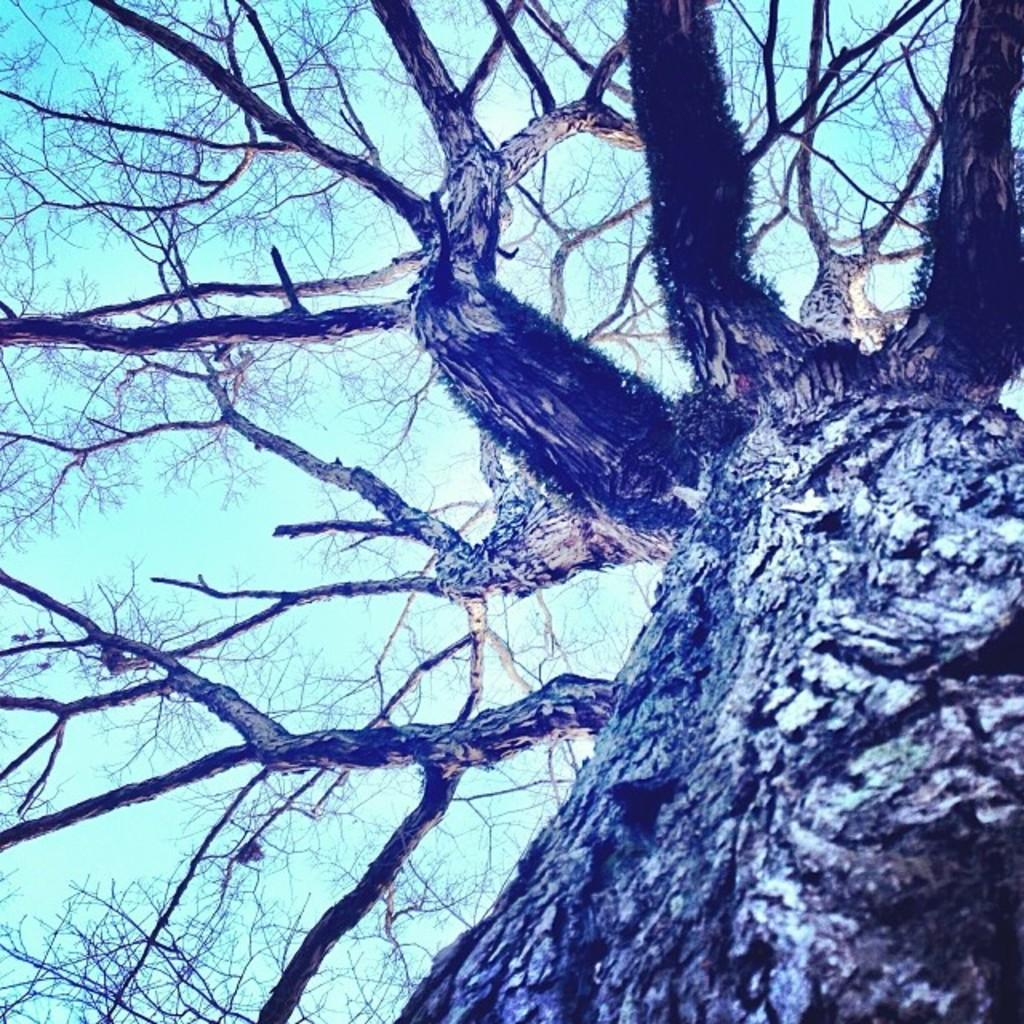What is the main subject in the foreground of the image? There is a tree trunk in the foreground of the image. What can be observed about the tree's branches in the image? The branches of the tree are visible without leaves. What part of the natural environment is visible in the image? The sky is visible in the image. What type of dust can be seen settling on the station in the image? There is no station or dust present in the image; it features a tree trunk with visible branches and a visible sky. 